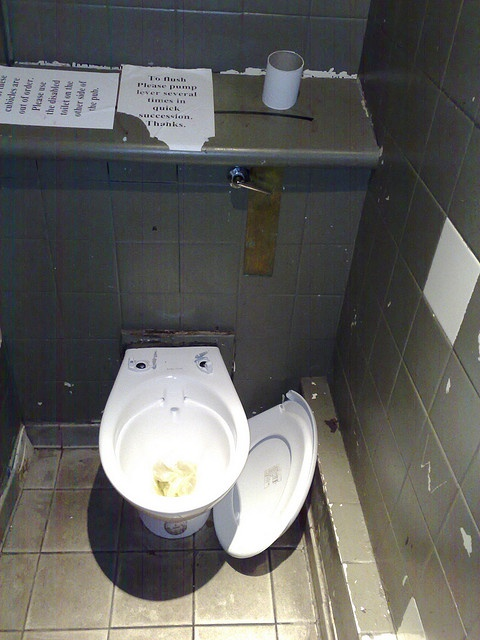Describe the objects in this image and their specific colors. I can see a toilet in black, white, darkgray, and gray tones in this image. 